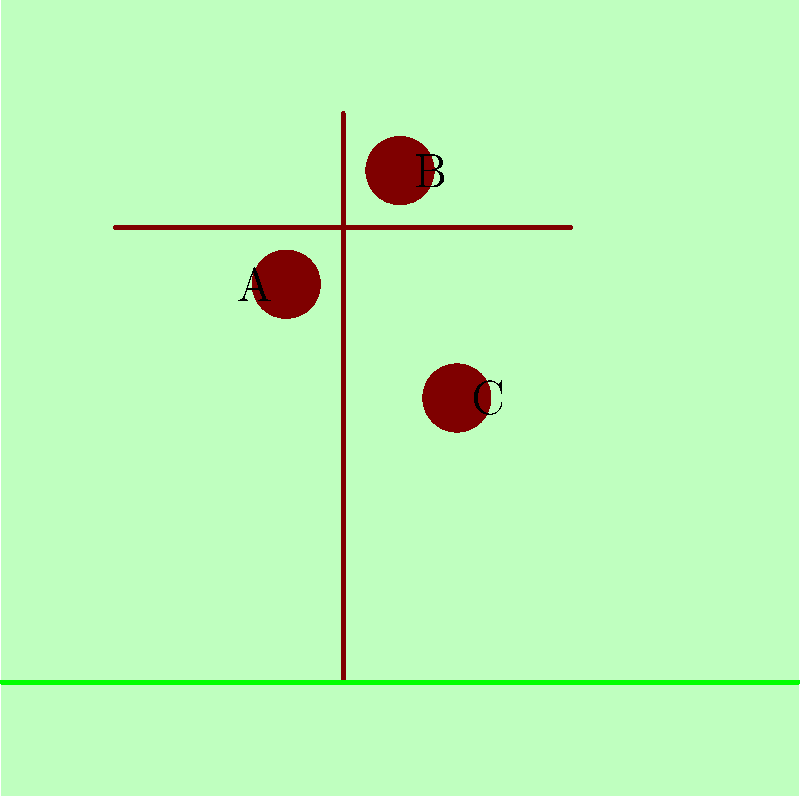In the image above, three bird nests (A, B, and C) are shown in different locations on a tree. Based on your knowledge of bird nesting habits and the guidance from Dara M. Wilson's field guides, which nest is most likely to belong to a Northern Cardinal? To answer this question, let's consider the nesting habits of Northern Cardinals and compare them to the locations of the nests in the image:

1. Northern Cardinals typically nest in dense shrubs, small trees, or tangled vines.
2. They prefer to build their nests at heights between 3-10 feet off the ground.
3. Cardinals often choose locations that provide good cover and protection from predators.

Now, let's analyze each nest:

A. This nest is located in the middle of the tree, at a moderate height. It's well-concealed by branches, which provides good protection.
B. This nest is positioned at the top of the tree, which is higher than Cardinals typically prefer. It's also more exposed, making it less suitable for Cardinals.
C. This nest is lower on the tree, closer to the ground. While Cardinals can nest at this height, it's not as ideal as a slightly higher location.

Considering these factors, nest A best matches the typical nesting habits of Northern Cardinals. It's at a suitable height, well-protected by surrounding branches, and provides good cover.
Answer: A 